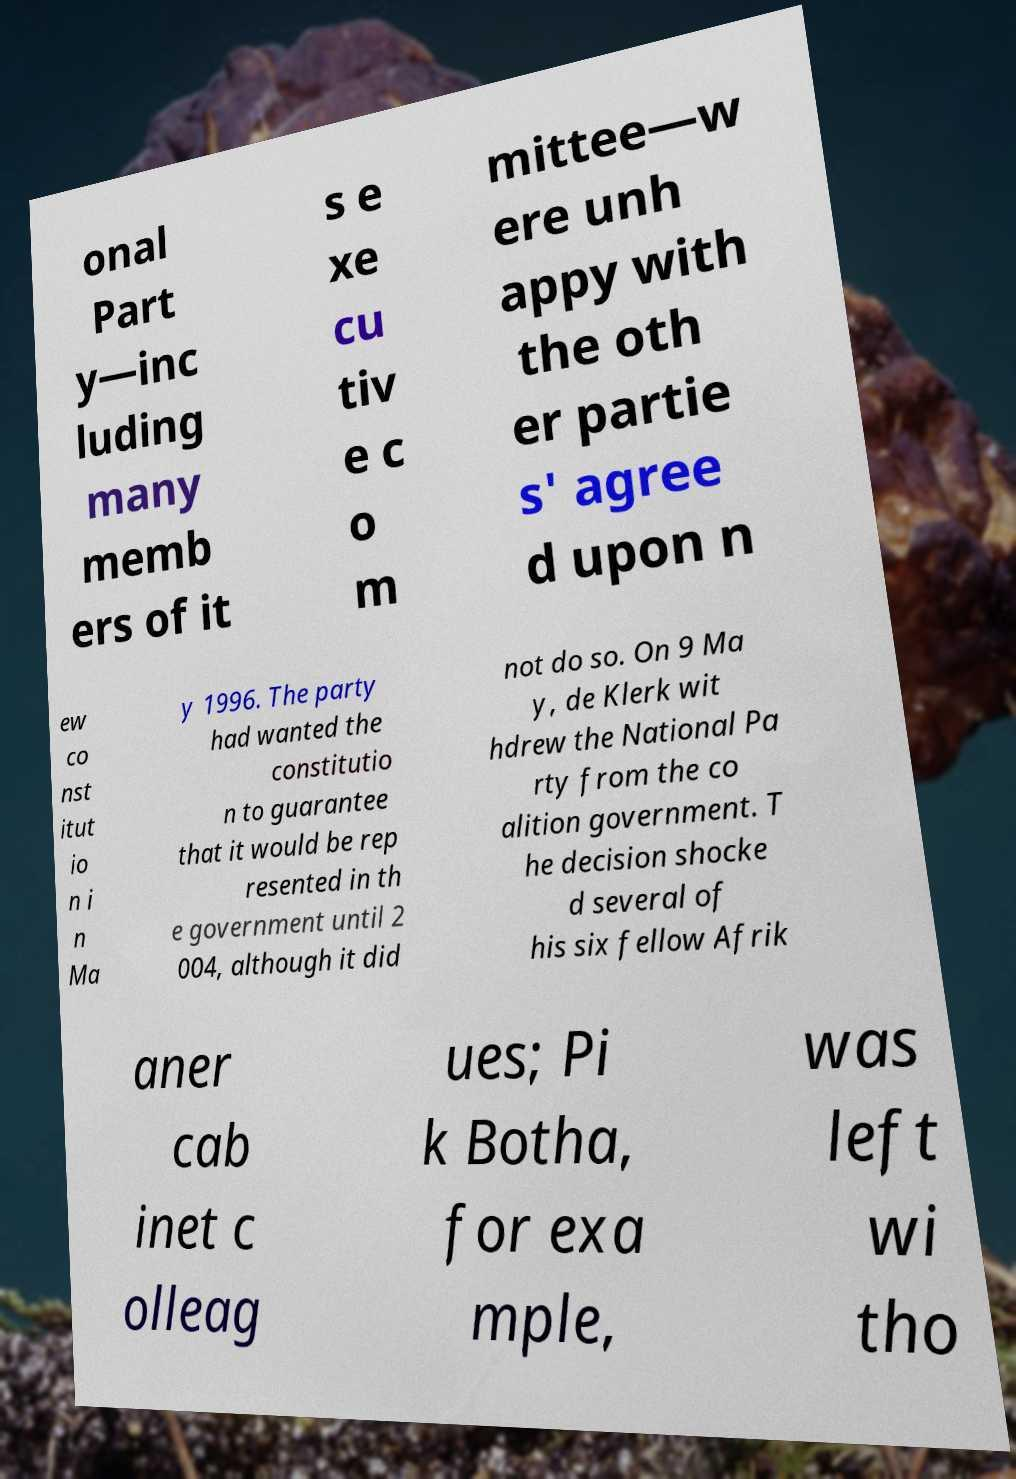For documentation purposes, I need the text within this image transcribed. Could you provide that? onal Part y—inc luding many memb ers of it s e xe cu tiv e c o m mittee—w ere unh appy with the oth er partie s' agree d upon n ew co nst itut io n i n Ma y 1996. The party had wanted the constitutio n to guarantee that it would be rep resented in th e government until 2 004, although it did not do so. On 9 Ma y, de Klerk wit hdrew the National Pa rty from the co alition government. T he decision shocke d several of his six fellow Afrik aner cab inet c olleag ues; Pi k Botha, for exa mple, was left wi tho 